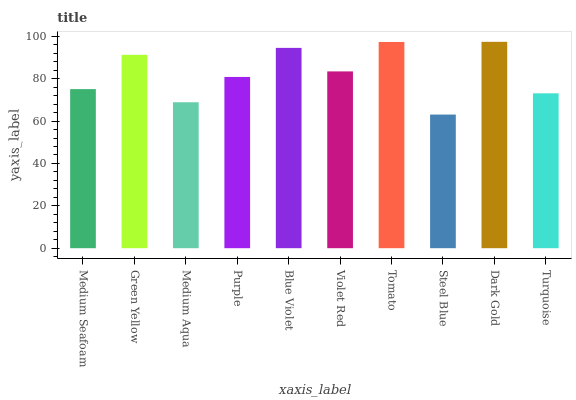Is Steel Blue the minimum?
Answer yes or no. Yes. Is Dark Gold the maximum?
Answer yes or no. Yes. Is Green Yellow the minimum?
Answer yes or no. No. Is Green Yellow the maximum?
Answer yes or no. No. Is Green Yellow greater than Medium Seafoam?
Answer yes or no. Yes. Is Medium Seafoam less than Green Yellow?
Answer yes or no. Yes. Is Medium Seafoam greater than Green Yellow?
Answer yes or no. No. Is Green Yellow less than Medium Seafoam?
Answer yes or no. No. Is Violet Red the high median?
Answer yes or no. Yes. Is Purple the low median?
Answer yes or no. Yes. Is Steel Blue the high median?
Answer yes or no. No. Is Medium Aqua the low median?
Answer yes or no. No. 